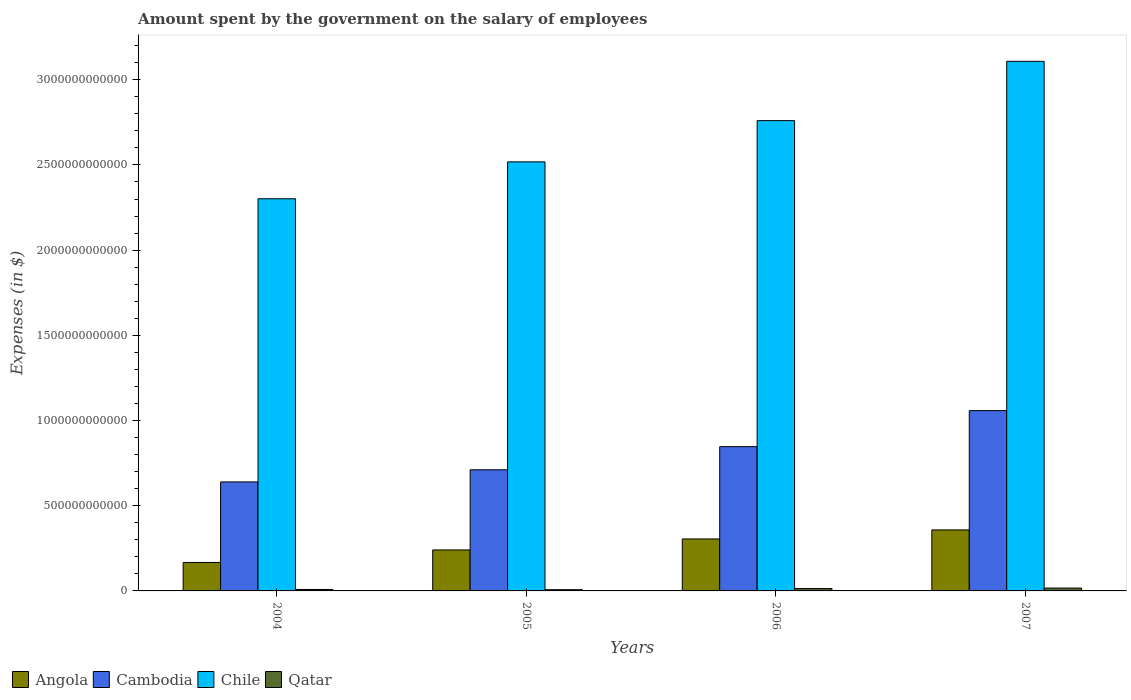How many different coloured bars are there?
Provide a short and direct response. 4. How many bars are there on the 1st tick from the left?
Offer a terse response. 4. How many bars are there on the 2nd tick from the right?
Make the answer very short. 4. What is the label of the 4th group of bars from the left?
Ensure brevity in your answer.  2007. In how many cases, is the number of bars for a given year not equal to the number of legend labels?
Ensure brevity in your answer.  0. What is the amount spent on the salary of employees by the government in Qatar in 2005?
Keep it short and to the point. 7.23e+09. Across all years, what is the maximum amount spent on the salary of employees by the government in Angola?
Give a very brief answer. 3.58e+11. Across all years, what is the minimum amount spent on the salary of employees by the government in Qatar?
Provide a succinct answer. 7.23e+09. What is the total amount spent on the salary of employees by the government in Cambodia in the graph?
Offer a very short reply. 3.26e+12. What is the difference between the amount spent on the salary of employees by the government in Angola in 2004 and that in 2006?
Provide a succinct answer. -1.38e+11. What is the difference between the amount spent on the salary of employees by the government in Cambodia in 2007 and the amount spent on the salary of employees by the government in Chile in 2006?
Make the answer very short. -1.70e+12. What is the average amount spent on the salary of employees by the government in Angola per year?
Provide a succinct answer. 2.68e+11. In the year 2004, what is the difference between the amount spent on the salary of employees by the government in Cambodia and amount spent on the salary of employees by the government in Angola?
Your answer should be compact. 4.73e+11. What is the ratio of the amount spent on the salary of employees by the government in Chile in 2004 to that in 2007?
Your answer should be very brief. 0.74. Is the amount spent on the salary of employees by the government in Angola in 2004 less than that in 2005?
Offer a very short reply. Yes. What is the difference between the highest and the second highest amount spent on the salary of employees by the government in Qatar?
Your answer should be very brief. 2.72e+09. What is the difference between the highest and the lowest amount spent on the salary of employees by the government in Qatar?
Offer a very short reply. 9.51e+09. In how many years, is the amount spent on the salary of employees by the government in Qatar greater than the average amount spent on the salary of employees by the government in Qatar taken over all years?
Provide a succinct answer. 2. Is the sum of the amount spent on the salary of employees by the government in Angola in 2004 and 2005 greater than the maximum amount spent on the salary of employees by the government in Chile across all years?
Your answer should be compact. No. What does the 4th bar from the left in 2005 represents?
Your response must be concise. Qatar. What does the 4th bar from the right in 2007 represents?
Offer a terse response. Angola. Is it the case that in every year, the sum of the amount spent on the salary of employees by the government in Cambodia and amount spent on the salary of employees by the government in Angola is greater than the amount spent on the salary of employees by the government in Chile?
Keep it short and to the point. No. How many bars are there?
Give a very brief answer. 16. Are all the bars in the graph horizontal?
Your response must be concise. No. What is the difference between two consecutive major ticks on the Y-axis?
Your response must be concise. 5.00e+11. Are the values on the major ticks of Y-axis written in scientific E-notation?
Provide a short and direct response. No. Does the graph contain any zero values?
Your answer should be very brief. No. Does the graph contain grids?
Your answer should be compact. No. How many legend labels are there?
Provide a succinct answer. 4. What is the title of the graph?
Provide a succinct answer. Amount spent by the government on the salary of employees. Does "Brazil" appear as one of the legend labels in the graph?
Ensure brevity in your answer.  No. What is the label or title of the Y-axis?
Your response must be concise. Expenses (in $). What is the Expenses (in $) in Angola in 2004?
Ensure brevity in your answer.  1.67e+11. What is the Expenses (in $) of Cambodia in 2004?
Ensure brevity in your answer.  6.40e+11. What is the Expenses (in $) in Chile in 2004?
Offer a terse response. 2.30e+12. What is the Expenses (in $) in Qatar in 2004?
Offer a very short reply. 8.66e+09. What is the Expenses (in $) in Angola in 2005?
Offer a terse response. 2.41e+11. What is the Expenses (in $) in Cambodia in 2005?
Keep it short and to the point. 7.11e+11. What is the Expenses (in $) in Chile in 2005?
Offer a terse response. 2.52e+12. What is the Expenses (in $) in Qatar in 2005?
Provide a succinct answer. 7.23e+09. What is the Expenses (in $) of Angola in 2006?
Keep it short and to the point. 3.05e+11. What is the Expenses (in $) of Cambodia in 2006?
Keep it short and to the point. 8.47e+11. What is the Expenses (in $) of Chile in 2006?
Keep it short and to the point. 2.76e+12. What is the Expenses (in $) in Qatar in 2006?
Provide a short and direct response. 1.40e+1. What is the Expenses (in $) of Angola in 2007?
Offer a very short reply. 3.58e+11. What is the Expenses (in $) in Cambodia in 2007?
Your response must be concise. 1.06e+12. What is the Expenses (in $) in Chile in 2007?
Give a very brief answer. 3.11e+12. What is the Expenses (in $) in Qatar in 2007?
Make the answer very short. 1.67e+1. Across all years, what is the maximum Expenses (in $) in Angola?
Offer a very short reply. 3.58e+11. Across all years, what is the maximum Expenses (in $) of Cambodia?
Your response must be concise. 1.06e+12. Across all years, what is the maximum Expenses (in $) in Chile?
Give a very brief answer. 3.11e+12. Across all years, what is the maximum Expenses (in $) in Qatar?
Your answer should be very brief. 1.67e+1. Across all years, what is the minimum Expenses (in $) in Angola?
Ensure brevity in your answer.  1.67e+11. Across all years, what is the minimum Expenses (in $) of Cambodia?
Provide a short and direct response. 6.40e+11. Across all years, what is the minimum Expenses (in $) in Chile?
Give a very brief answer. 2.30e+12. Across all years, what is the minimum Expenses (in $) of Qatar?
Provide a succinct answer. 7.23e+09. What is the total Expenses (in $) in Angola in the graph?
Make the answer very short. 1.07e+12. What is the total Expenses (in $) in Cambodia in the graph?
Keep it short and to the point. 3.26e+12. What is the total Expenses (in $) in Chile in the graph?
Your response must be concise. 1.07e+13. What is the total Expenses (in $) of Qatar in the graph?
Provide a succinct answer. 4.67e+1. What is the difference between the Expenses (in $) of Angola in 2004 and that in 2005?
Keep it short and to the point. -7.36e+1. What is the difference between the Expenses (in $) of Cambodia in 2004 and that in 2005?
Ensure brevity in your answer.  -7.13e+1. What is the difference between the Expenses (in $) in Chile in 2004 and that in 2005?
Offer a very short reply. -2.16e+11. What is the difference between the Expenses (in $) of Qatar in 2004 and that in 2005?
Offer a very short reply. 1.43e+09. What is the difference between the Expenses (in $) in Angola in 2004 and that in 2006?
Provide a succinct answer. -1.38e+11. What is the difference between the Expenses (in $) of Cambodia in 2004 and that in 2006?
Ensure brevity in your answer.  -2.07e+11. What is the difference between the Expenses (in $) of Chile in 2004 and that in 2006?
Provide a succinct answer. -4.58e+11. What is the difference between the Expenses (in $) in Qatar in 2004 and that in 2006?
Offer a very short reply. -5.36e+09. What is the difference between the Expenses (in $) in Angola in 2004 and that in 2007?
Your answer should be compact. -1.91e+11. What is the difference between the Expenses (in $) of Cambodia in 2004 and that in 2007?
Offer a very short reply. -4.18e+11. What is the difference between the Expenses (in $) in Chile in 2004 and that in 2007?
Your answer should be very brief. -8.06e+11. What is the difference between the Expenses (in $) of Qatar in 2004 and that in 2007?
Your response must be concise. -8.08e+09. What is the difference between the Expenses (in $) in Angola in 2005 and that in 2006?
Ensure brevity in your answer.  -6.44e+1. What is the difference between the Expenses (in $) of Cambodia in 2005 and that in 2006?
Your answer should be compact. -1.36e+11. What is the difference between the Expenses (in $) in Chile in 2005 and that in 2006?
Offer a very short reply. -2.42e+11. What is the difference between the Expenses (in $) of Qatar in 2005 and that in 2006?
Ensure brevity in your answer.  -6.79e+09. What is the difference between the Expenses (in $) of Angola in 2005 and that in 2007?
Keep it short and to the point. -1.17e+11. What is the difference between the Expenses (in $) in Cambodia in 2005 and that in 2007?
Your answer should be very brief. -3.47e+11. What is the difference between the Expenses (in $) of Chile in 2005 and that in 2007?
Give a very brief answer. -5.90e+11. What is the difference between the Expenses (in $) in Qatar in 2005 and that in 2007?
Your response must be concise. -9.51e+09. What is the difference between the Expenses (in $) of Angola in 2006 and that in 2007?
Offer a terse response. -5.30e+1. What is the difference between the Expenses (in $) in Cambodia in 2006 and that in 2007?
Keep it short and to the point. -2.12e+11. What is the difference between the Expenses (in $) in Chile in 2006 and that in 2007?
Your answer should be compact. -3.48e+11. What is the difference between the Expenses (in $) of Qatar in 2006 and that in 2007?
Ensure brevity in your answer.  -2.72e+09. What is the difference between the Expenses (in $) of Angola in 2004 and the Expenses (in $) of Cambodia in 2005?
Your response must be concise. -5.44e+11. What is the difference between the Expenses (in $) of Angola in 2004 and the Expenses (in $) of Chile in 2005?
Offer a very short reply. -2.35e+12. What is the difference between the Expenses (in $) of Angola in 2004 and the Expenses (in $) of Qatar in 2005?
Provide a short and direct response. 1.60e+11. What is the difference between the Expenses (in $) of Cambodia in 2004 and the Expenses (in $) of Chile in 2005?
Offer a terse response. -1.88e+12. What is the difference between the Expenses (in $) of Cambodia in 2004 and the Expenses (in $) of Qatar in 2005?
Provide a short and direct response. 6.32e+11. What is the difference between the Expenses (in $) of Chile in 2004 and the Expenses (in $) of Qatar in 2005?
Your answer should be compact. 2.29e+12. What is the difference between the Expenses (in $) of Angola in 2004 and the Expenses (in $) of Cambodia in 2006?
Your response must be concise. -6.80e+11. What is the difference between the Expenses (in $) in Angola in 2004 and the Expenses (in $) in Chile in 2006?
Your response must be concise. -2.59e+12. What is the difference between the Expenses (in $) of Angola in 2004 and the Expenses (in $) of Qatar in 2006?
Give a very brief answer. 1.53e+11. What is the difference between the Expenses (in $) in Cambodia in 2004 and the Expenses (in $) in Chile in 2006?
Your answer should be compact. -2.12e+12. What is the difference between the Expenses (in $) of Cambodia in 2004 and the Expenses (in $) of Qatar in 2006?
Give a very brief answer. 6.26e+11. What is the difference between the Expenses (in $) of Chile in 2004 and the Expenses (in $) of Qatar in 2006?
Offer a terse response. 2.29e+12. What is the difference between the Expenses (in $) of Angola in 2004 and the Expenses (in $) of Cambodia in 2007?
Your response must be concise. -8.91e+11. What is the difference between the Expenses (in $) in Angola in 2004 and the Expenses (in $) in Chile in 2007?
Your response must be concise. -2.94e+12. What is the difference between the Expenses (in $) of Angola in 2004 and the Expenses (in $) of Qatar in 2007?
Provide a short and direct response. 1.50e+11. What is the difference between the Expenses (in $) of Cambodia in 2004 and the Expenses (in $) of Chile in 2007?
Ensure brevity in your answer.  -2.47e+12. What is the difference between the Expenses (in $) of Cambodia in 2004 and the Expenses (in $) of Qatar in 2007?
Keep it short and to the point. 6.23e+11. What is the difference between the Expenses (in $) in Chile in 2004 and the Expenses (in $) in Qatar in 2007?
Offer a terse response. 2.28e+12. What is the difference between the Expenses (in $) in Angola in 2005 and the Expenses (in $) in Cambodia in 2006?
Provide a short and direct response. -6.06e+11. What is the difference between the Expenses (in $) in Angola in 2005 and the Expenses (in $) in Chile in 2006?
Give a very brief answer. -2.52e+12. What is the difference between the Expenses (in $) of Angola in 2005 and the Expenses (in $) of Qatar in 2006?
Provide a short and direct response. 2.27e+11. What is the difference between the Expenses (in $) in Cambodia in 2005 and the Expenses (in $) in Chile in 2006?
Provide a short and direct response. -2.05e+12. What is the difference between the Expenses (in $) of Cambodia in 2005 and the Expenses (in $) of Qatar in 2006?
Offer a very short reply. 6.97e+11. What is the difference between the Expenses (in $) in Chile in 2005 and the Expenses (in $) in Qatar in 2006?
Offer a very short reply. 2.50e+12. What is the difference between the Expenses (in $) in Angola in 2005 and the Expenses (in $) in Cambodia in 2007?
Ensure brevity in your answer.  -8.18e+11. What is the difference between the Expenses (in $) in Angola in 2005 and the Expenses (in $) in Chile in 2007?
Make the answer very short. -2.87e+12. What is the difference between the Expenses (in $) in Angola in 2005 and the Expenses (in $) in Qatar in 2007?
Provide a short and direct response. 2.24e+11. What is the difference between the Expenses (in $) in Cambodia in 2005 and the Expenses (in $) in Chile in 2007?
Provide a short and direct response. -2.40e+12. What is the difference between the Expenses (in $) in Cambodia in 2005 and the Expenses (in $) in Qatar in 2007?
Offer a very short reply. 6.94e+11. What is the difference between the Expenses (in $) of Chile in 2005 and the Expenses (in $) of Qatar in 2007?
Give a very brief answer. 2.50e+12. What is the difference between the Expenses (in $) of Angola in 2006 and the Expenses (in $) of Cambodia in 2007?
Make the answer very short. -7.53e+11. What is the difference between the Expenses (in $) in Angola in 2006 and the Expenses (in $) in Chile in 2007?
Provide a succinct answer. -2.80e+12. What is the difference between the Expenses (in $) in Angola in 2006 and the Expenses (in $) in Qatar in 2007?
Your response must be concise. 2.88e+11. What is the difference between the Expenses (in $) of Cambodia in 2006 and the Expenses (in $) of Chile in 2007?
Your answer should be compact. -2.26e+12. What is the difference between the Expenses (in $) of Cambodia in 2006 and the Expenses (in $) of Qatar in 2007?
Offer a terse response. 8.30e+11. What is the difference between the Expenses (in $) in Chile in 2006 and the Expenses (in $) in Qatar in 2007?
Your answer should be very brief. 2.74e+12. What is the average Expenses (in $) of Angola per year?
Your answer should be compact. 2.68e+11. What is the average Expenses (in $) in Cambodia per year?
Your answer should be very brief. 8.14e+11. What is the average Expenses (in $) of Chile per year?
Keep it short and to the point. 2.67e+12. What is the average Expenses (in $) in Qatar per year?
Offer a very short reply. 1.17e+1. In the year 2004, what is the difference between the Expenses (in $) of Angola and Expenses (in $) of Cambodia?
Offer a terse response. -4.73e+11. In the year 2004, what is the difference between the Expenses (in $) of Angola and Expenses (in $) of Chile?
Keep it short and to the point. -2.13e+12. In the year 2004, what is the difference between the Expenses (in $) of Angola and Expenses (in $) of Qatar?
Keep it short and to the point. 1.58e+11. In the year 2004, what is the difference between the Expenses (in $) of Cambodia and Expenses (in $) of Chile?
Your answer should be very brief. -1.66e+12. In the year 2004, what is the difference between the Expenses (in $) of Cambodia and Expenses (in $) of Qatar?
Ensure brevity in your answer.  6.31e+11. In the year 2004, what is the difference between the Expenses (in $) of Chile and Expenses (in $) of Qatar?
Ensure brevity in your answer.  2.29e+12. In the year 2005, what is the difference between the Expenses (in $) of Angola and Expenses (in $) of Cambodia?
Make the answer very short. -4.70e+11. In the year 2005, what is the difference between the Expenses (in $) of Angola and Expenses (in $) of Chile?
Offer a very short reply. -2.28e+12. In the year 2005, what is the difference between the Expenses (in $) of Angola and Expenses (in $) of Qatar?
Offer a very short reply. 2.33e+11. In the year 2005, what is the difference between the Expenses (in $) of Cambodia and Expenses (in $) of Chile?
Provide a short and direct response. -1.81e+12. In the year 2005, what is the difference between the Expenses (in $) of Cambodia and Expenses (in $) of Qatar?
Offer a very short reply. 7.04e+11. In the year 2005, what is the difference between the Expenses (in $) of Chile and Expenses (in $) of Qatar?
Ensure brevity in your answer.  2.51e+12. In the year 2006, what is the difference between the Expenses (in $) in Angola and Expenses (in $) in Cambodia?
Ensure brevity in your answer.  -5.42e+11. In the year 2006, what is the difference between the Expenses (in $) in Angola and Expenses (in $) in Chile?
Provide a short and direct response. -2.45e+12. In the year 2006, what is the difference between the Expenses (in $) in Angola and Expenses (in $) in Qatar?
Your answer should be compact. 2.91e+11. In the year 2006, what is the difference between the Expenses (in $) in Cambodia and Expenses (in $) in Chile?
Make the answer very short. -1.91e+12. In the year 2006, what is the difference between the Expenses (in $) of Cambodia and Expenses (in $) of Qatar?
Give a very brief answer. 8.33e+11. In the year 2006, what is the difference between the Expenses (in $) in Chile and Expenses (in $) in Qatar?
Offer a very short reply. 2.75e+12. In the year 2007, what is the difference between the Expenses (in $) of Angola and Expenses (in $) of Cambodia?
Provide a succinct answer. -7.00e+11. In the year 2007, what is the difference between the Expenses (in $) of Angola and Expenses (in $) of Chile?
Keep it short and to the point. -2.75e+12. In the year 2007, what is the difference between the Expenses (in $) in Angola and Expenses (in $) in Qatar?
Offer a very short reply. 3.41e+11. In the year 2007, what is the difference between the Expenses (in $) in Cambodia and Expenses (in $) in Chile?
Offer a terse response. -2.05e+12. In the year 2007, what is the difference between the Expenses (in $) of Cambodia and Expenses (in $) of Qatar?
Ensure brevity in your answer.  1.04e+12. In the year 2007, what is the difference between the Expenses (in $) of Chile and Expenses (in $) of Qatar?
Provide a short and direct response. 3.09e+12. What is the ratio of the Expenses (in $) of Angola in 2004 to that in 2005?
Keep it short and to the point. 0.69. What is the ratio of the Expenses (in $) of Cambodia in 2004 to that in 2005?
Keep it short and to the point. 0.9. What is the ratio of the Expenses (in $) of Chile in 2004 to that in 2005?
Provide a short and direct response. 0.91. What is the ratio of the Expenses (in $) in Qatar in 2004 to that in 2005?
Provide a short and direct response. 1.2. What is the ratio of the Expenses (in $) of Angola in 2004 to that in 2006?
Provide a short and direct response. 0.55. What is the ratio of the Expenses (in $) in Cambodia in 2004 to that in 2006?
Make the answer very short. 0.76. What is the ratio of the Expenses (in $) of Chile in 2004 to that in 2006?
Your answer should be compact. 0.83. What is the ratio of the Expenses (in $) of Qatar in 2004 to that in 2006?
Your response must be concise. 0.62. What is the ratio of the Expenses (in $) in Angola in 2004 to that in 2007?
Offer a very short reply. 0.47. What is the ratio of the Expenses (in $) in Cambodia in 2004 to that in 2007?
Your answer should be very brief. 0.6. What is the ratio of the Expenses (in $) of Chile in 2004 to that in 2007?
Keep it short and to the point. 0.74. What is the ratio of the Expenses (in $) in Qatar in 2004 to that in 2007?
Provide a succinct answer. 0.52. What is the ratio of the Expenses (in $) in Angola in 2005 to that in 2006?
Provide a succinct answer. 0.79. What is the ratio of the Expenses (in $) of Cambodia in 2005 to that in 2006?
Offer a terse response. 0.84. What is the ratio of the Expenses (in $) of Chile in 2005 to that in 2006?
Give a very brief answer. 0.91. What is the ratio of the Expenses (in $) in Qatar in 2005 to that in 2006?
Your answer should be very brief. 0.52. What is the ratio of the Expenses (in $) in Angola in 2005 to that in 2007?
Offer a very short reply. 0.67. What is the ratio of the Expenses (in $) of Cambodia in 2005 to that in 2007?
Your answer should be very brief. 0.67. What is the ratio of the Expenses (in $) of Chile in 2005 to that in 2007?
Provide a succinct answer. 0.81. What is the ratio of the Expenses (in $) in Qatar in 2005 to that in 2007?
Provide a short and direct response. 0.43. What is the ratio of the Expenses (in $) in Angola in 2006 to that in 2007?
Provide a short and direct response. 0.85. What is the ratio of the Expenses (in $) of Cambodia in 2006 to that in 2007?
Provide a succinct answer. 0.8. What is the ratio of the Expenses (in $) of Chile in 2006 to that in 2007?
Ensure brevity in your answer.  0.89. What is the ratio of the Expenses (in $) of Qatar in 2006 to that in 2007?
Offer a terse response. 0.84. What is the difference between the highest and the second highest Expenses (in $) of Angola?
Keep it short and to the point. 5.30e+1. What is the difference between the highest and the second highest Expenses (in $) of Cambodia?
Your answer should be compact. 2.12e+11. What is the difference between the highest and the second highest Expenses (in $) in Chile?
Give a very brief answer. 3.48e+11. What is the difference between the highest and the second highest Expenses (in $) of Qatar?
Your answer should be very brief. 2.72e+09. What is the difference between the highest and the lowest Expenses (in $) of Angola?
Your answer should be very brief. 1.91e+11. What is the difference between the highest and the lowest Expenses (in $) in Cambodia?
Provide a succinct answer. 4.18e+11. What is the difference between the highest and the lowest Expenses (in $) of Chile?
Give a very brief answer. 8.06e+11. What is the difference between the highest and the lowest Expenses (in $) in Qatar?
Your answer should be compact. 9.51e+09. 